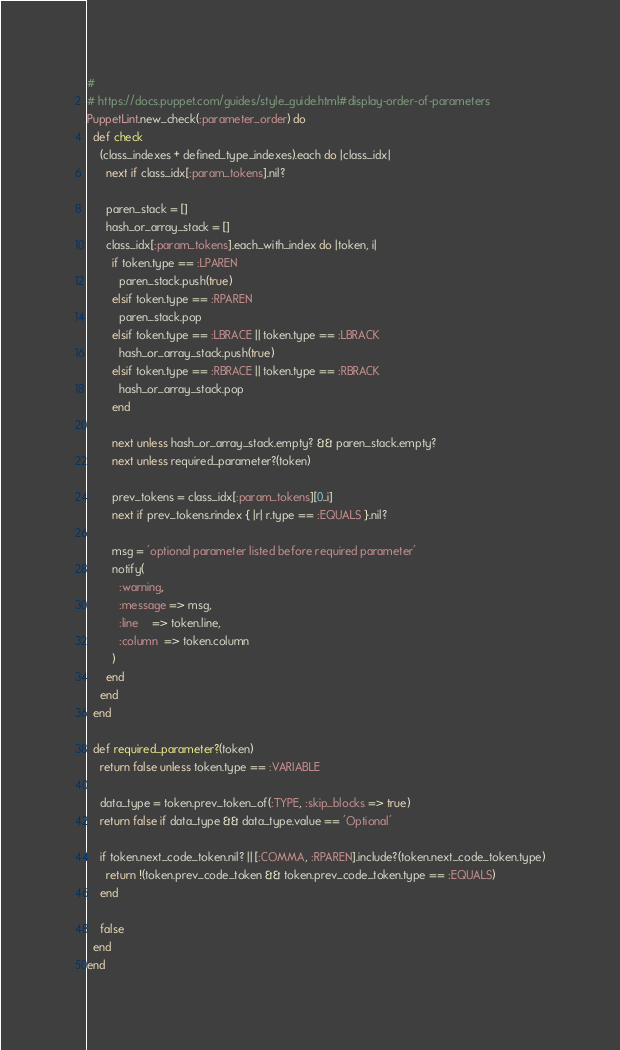<code> <loc_0><loc_0><loc_500><loc_500><_Ruby_>#
# https://docs.puppet.com/guides/style_guide.html#display-order-of-parameters
PuppetLint.new_check(:parameter_order) do
  def check
    (class_indexes + defined_type_indexes).each do |class_idx|
      next if class_idx[:param_tokens].nil?

      paren_stack = []
      hash_or_array_stack = []
      class_idx[:param_tokens].each_with_index do |token, i|
        if token.type == :LPAREN
          paren_stack.push(true)
        elsif token.type == :RPAREN
          paren_stack.pop
        elsif token.type == :LBRACE || token.type == :LBRACK
          hash_or_array_stack.push(true)
        elsif token.type == :RBRACE || token.type == :RBRACK
          hash_or_array_stack.pop
        end

        next unless hash_or_array_stack.empty? && paren_stack.empty?
        next unless required_parameter?(token)

        prev_tokens = class_idx[:param_tokens][0..i]
        next if prev_tokens.rindex { |r| r.type == :EQUALS }.nil?

        msg = 'optional parameter listed before required parameter'
        notify(
          :warning,
          :message => msg,
          :line    => token.line,
          :column  => token.column
        )
      end
    end
  end

  def required_parameter?(token)
    return false unless token.type == :VARIABLE

    data_type = token.prev_token_of(:TYPE, :skip_blocks => true)
    return false if data_type && data_type.value == 'Optional'

    if token.next_code_token.nil? || [:COMMA, :RPAREN].include?(token.next_code_token.type)
      return !(token.prev_code_token && token.prev_code_token.type == :EQUALS)
    end

    false
  end
end
</code> 